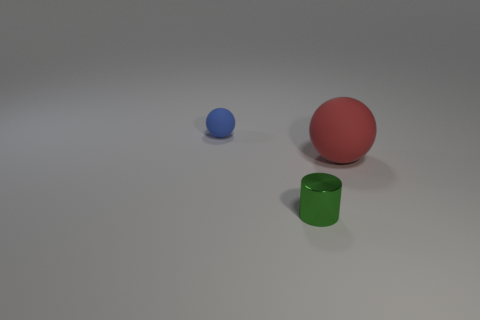What is the size of the sphere left of the sphere that is to the right of the tiny green cylinder?
Provide a succinct answer. Small. There is a small object right of the tiny thing that is to the left of the small green metallic cylinder; what is its material?
Your answer should be very brief. Metal. The thing that is made of the same material as the tiny sphere is what color?
Your answer should be compact. Red. There is a green cylinder that is in front of the big red matte thing; is its size the same as the thing on the left side of the small green metallic thing?
Your answer should be compact. Yes. What number of cylinders are tiny red metallic things or small matte objects?
Your answer should be compact. 0. Is the material of the tiny object that is behind the big thing the same as the cylinder?
Your answer should be compact. No. What number of other things are there of the same size as the red rubber ball?
Offer a terse response. 0. How many small objects are green cylinders or red objects?
Your response must be concise. 1. Is the number of big things that are on the right side of the small cylinder greater than the number of tiny blue objects that are behind the small blue thing?
Provide a succinct answer. Yes. Is there anything else of the same color as the big matte object?
Provide a succinct answer. No. 